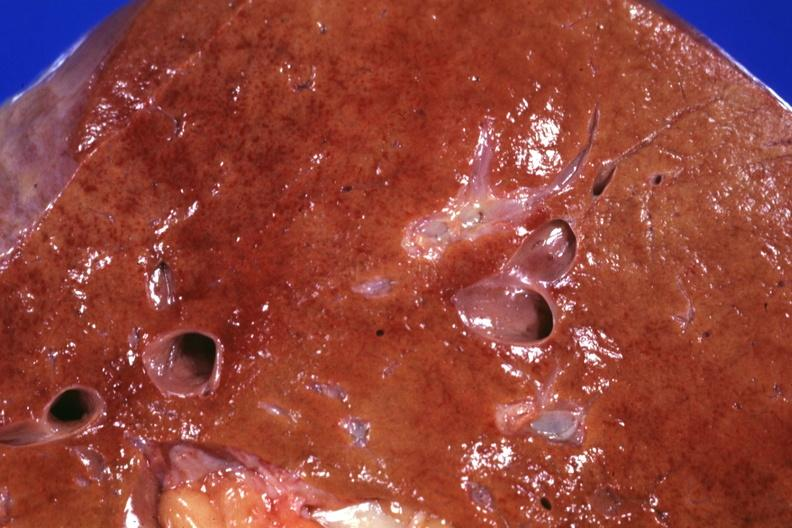what does this image show?
Answer the question using a single word or phrase. Close-up fatty with congestion and areas that suggest necrosis grossly good example shock liver 